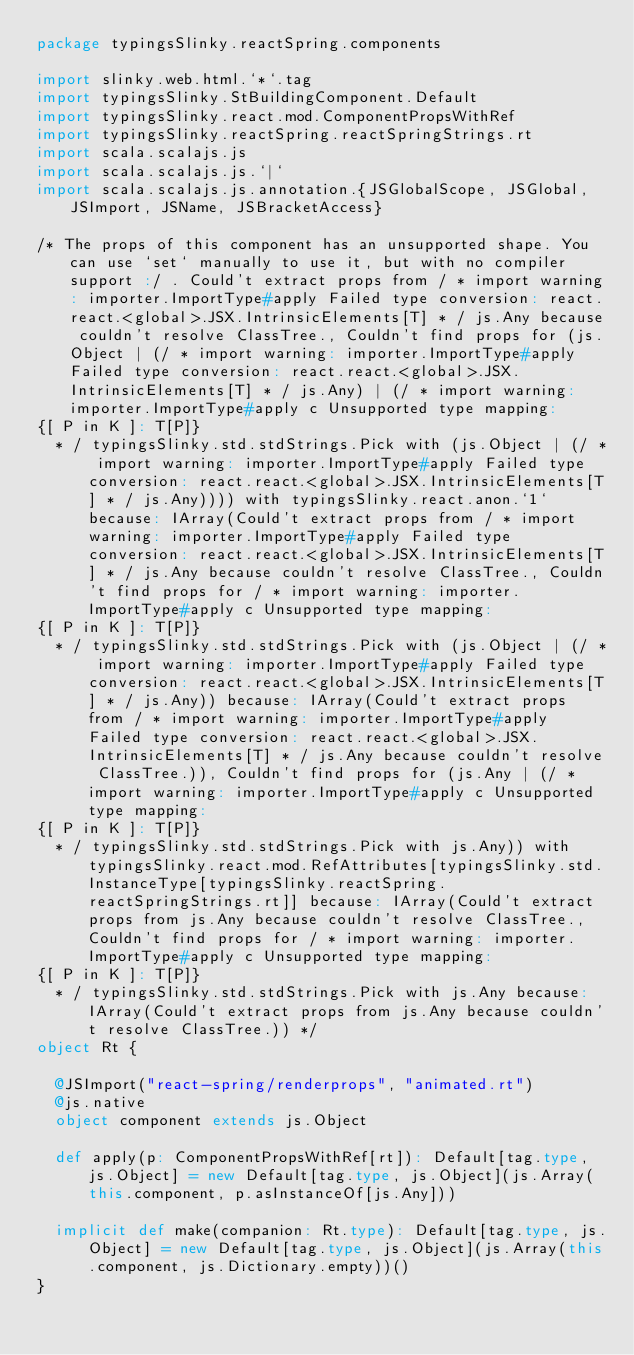Convert code to text. <code><loc_0><loc_0><loc_500><loc_500><_Scala_>package typingsSlinky.reactSpring.components

import slinky.web.html.`*`.tag
import typingsSlinky.StBuildingComponent.Default
import typingsSlinky.react.mod.ComponentPropsWithRef
import typingsSlinky.reactSpring.reactSpringStrings.rt
import scala.scalajs.js
import scala.scalajs.js.`|`
import scala.scalajs.js.annotation.{JSGlobalScope, JSGlobal, JSImport, JSName, JSBracketAccess}

/* The props of this component has an unsupported shape. You can use `set` manually to use it, but with no compiler support :/ . Could't extract props from / * import warning: importer.ImportType#apply Failed type conversion: react.react.<global>.JSX.IntrinsicElements[T] * / js.Any because couldn't resolve ClassTree., Couldn't find props for (js.Object | (/ * import warning: importer.ImportType#apply Failed type conversion: react.react.<global>.JSX.IntrinsicElements[T] * / js.Any) | (/ * import warning: importer.ImportType#apply c Unsupported type mapping: 
{[ P in K ]: T[P]}
  * / typingsSlinky.std.stdStrings.Pick with (js.Object | (/ * import warning: importer.ImportType#apply Failed type conversion: react.react.<global>.JSX.IntrinsicElements[T] * / js.Any)))) with typingsSlinky.react.anon.`1` because: IArray(Could't extract props from / * import warning: importer.ImportType#apply Failed type conversion: react.react.<global>.JSX.IntrinsicElements[T] * / js.Any because couldn't resolve ClassTree., Couldn't find props for / * import warning: importer.ImportType#apply c Unsupported type mapping: 
{[ P in K ]: T[P]}
  * / typingsSlinky.std.stdStrings.Pick with (js.Object | (/ * import warning: importer.ImportType#apply Failed type conversion: react.react.<global>.JSX.IntrinsicElements[T] * / js.Any)) because: IArray(Could't extract props from / * import warning: importer.ImportType#apply Failed type conversion: react.react.<global>.JSX.IntrinsicElements[T] * / js.Any because couldn't resolve ClassTree.)), Couldn't find props for (js.Any | (/ * import warning: importer.ImportType#apply c Unsupported type mapping: 
{[ P in K ]: T[P]}
  * / typingsSlinky.std.stdStrings.Pick with js.Any)) with typingsSlinky.react.mod.RefAttributes[typingsSlinky.std.InstanceType[typingsSlinky.reactSpring.reactSpringStrings.rt]] because: IArray(Could't extract props from js.Any because couldn't resolve ClassTree., Couldn't find props for / * import warning: importer.ImportType#apply c Unsupported type mapping: 
{[ P in K ]: T[P]}
  * / typingsSlinky.std.stdStrings.Pick with js.Any because: IArray(Could't extract props from js.Any because couldn't resolve ClassTree.)) */
object Rt {
  
  @JSImport("react-spring/renderprops", "animated.rt")
  @js.native
  object component extends js.Object
  
  def apply(p: ComponentPropsWithRef[rt]): Default[tag.type, js.Object] = new Default[tag.type, js.Object](js.Array(this.component, p.asInstanceOf[js.Any]))
  
  implicit def make(companion: Rt.type): Default[tag.type, js.Object] = new Default[tag.type, js.Object](js.Array(this.component, js.Dictionary.empty))()
}
</code> 